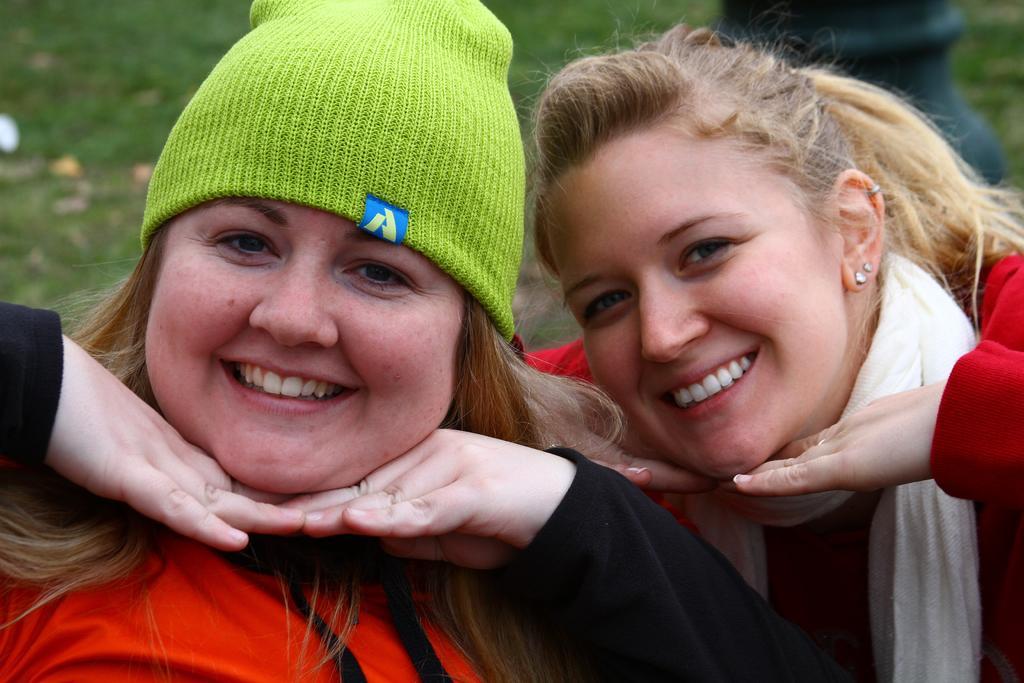How would you summarize this image in a sentence or two? In this picture we can see two women smiling. We can see a woman wearing a cap on the left side. Some grass is visible on the ground. We can see a black object in the background. Background is blurry. 